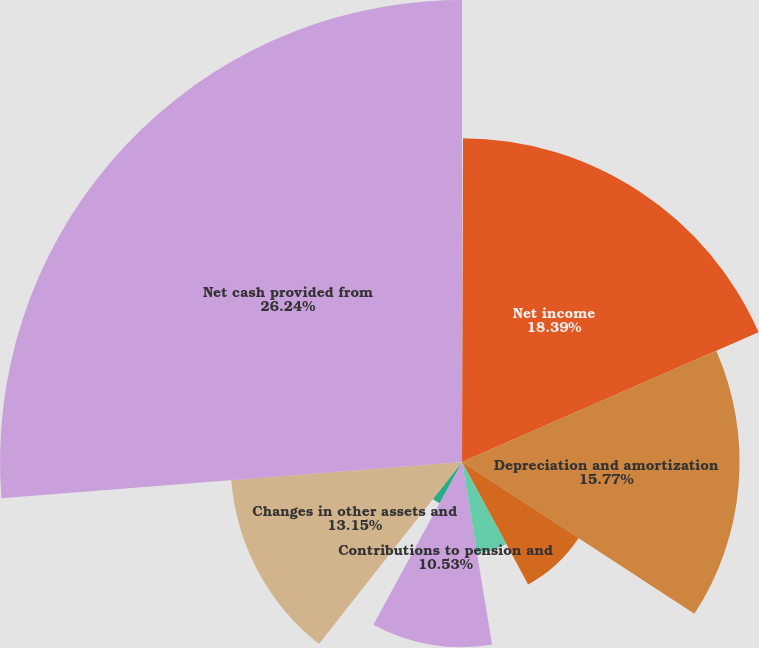Convert chart to OTSL. <chart><loc_0><loc_0><loc_500><loc_500><pie_chart><fcel>For the year s ended December<fcel>Net income<fcel>Depreciation and amortization<fcel>Stock-based compensation and<fcel>Deferred income taxes<fcel>Contributions to pension and<fcel>Working capital<fcel>Changes in other assets and<fcel>Net cash provided from<nl><fcel>0.05%<fcel>18.39%<fcel>15.77%<fcel>7.91%<fcel>5.29%<fcel>10.53%<fcel>2.67%<fcel>13.15%<fcel>26.25%<nl></chart> 